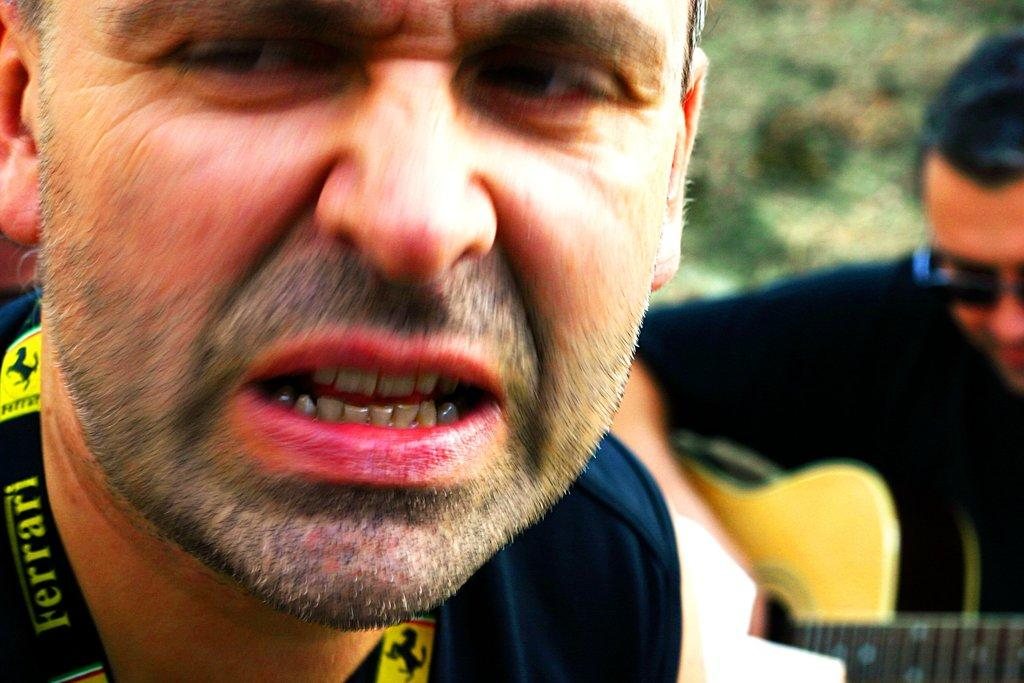How many people are in the image? There are two men in the image. What is one of the men wearing? One of the men is wearing goggles. What is one of the men doing in the image? One of the men is playing a guitar. What emotion is the mom expressing in the image? There is no mom present in the image, so it is not possible to determine her emotions. 